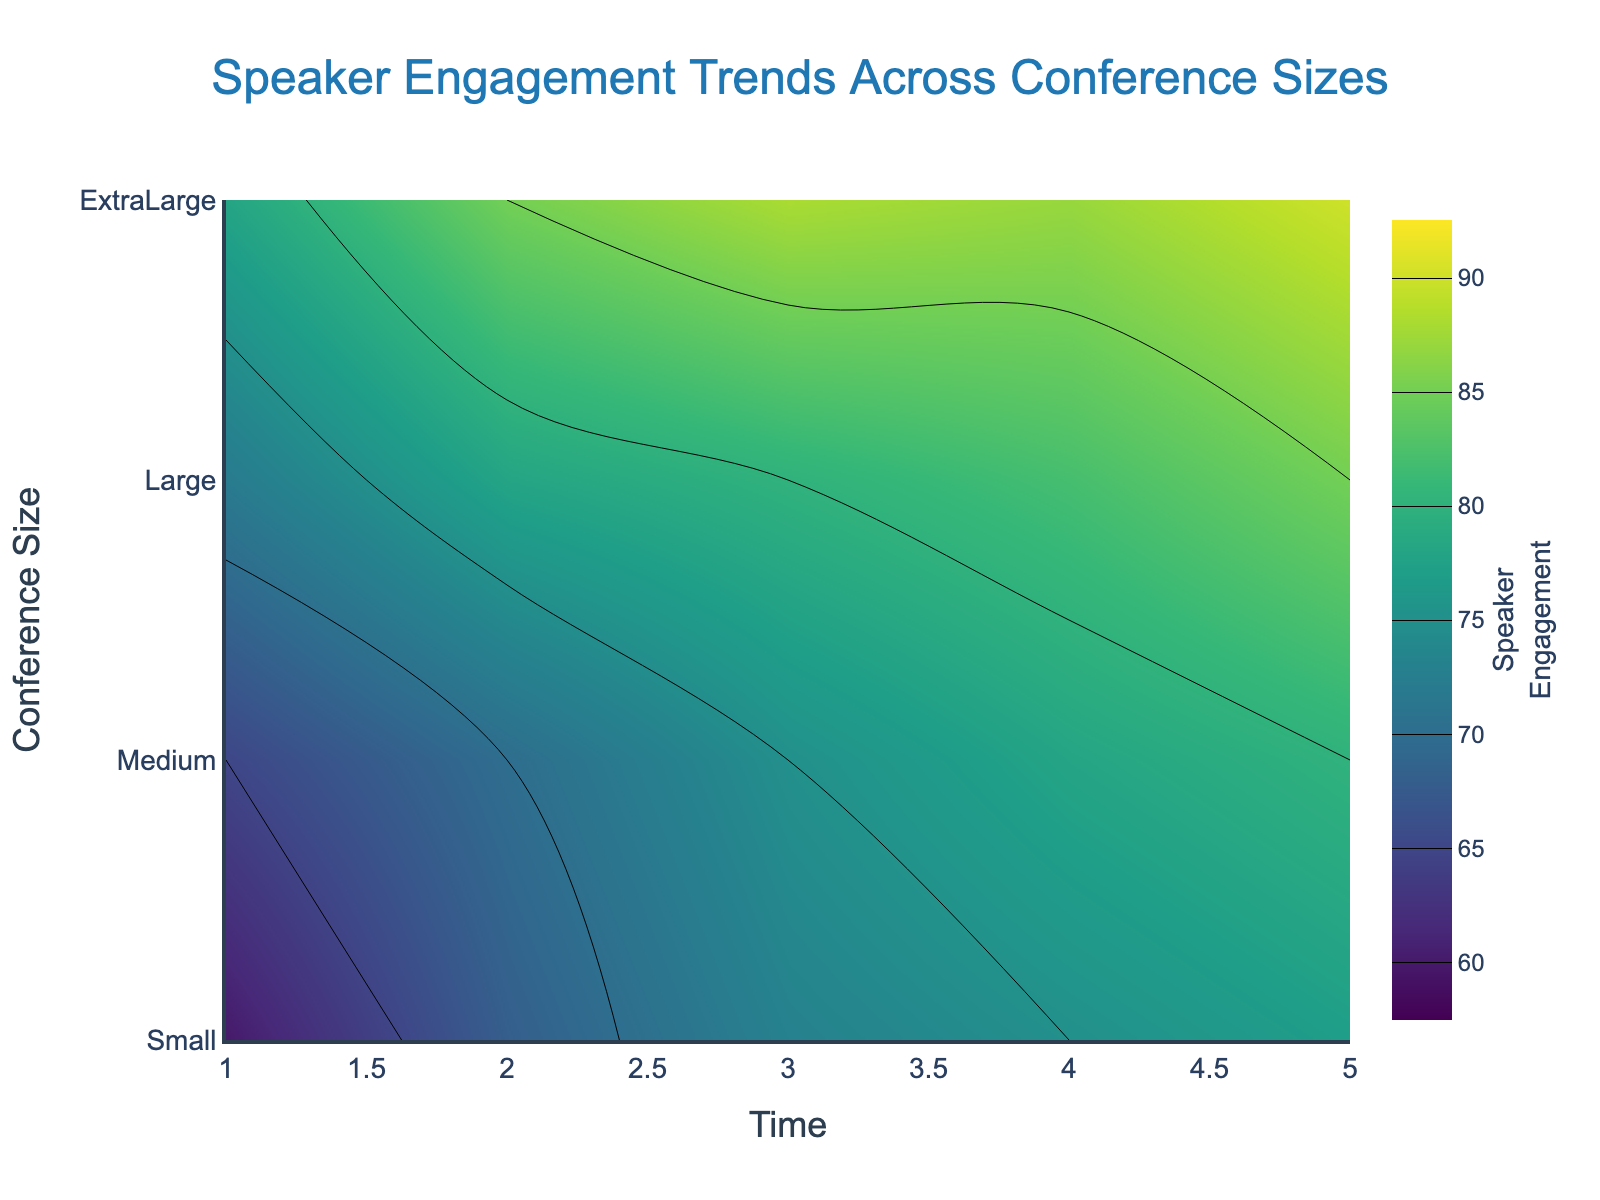How does speaker engagement change over time for a medium-sized conference? Speaker engagement for a medium-sized conference increases steadily from 72 to 85 as the time progresses from 1 to 5.
Answer: It increases from 72 to 85 Which conference size shows the highest initial speaker engagement? The small-sized conference shows the highest initial speaker engagement of 78, compared to medium (72), large (65), and extra-large (60) sizes.
Answer: Small Between which two time points is the increase in speaker engagement the highest for a large conference? For a large conference, the increase in speaker engagement is highest between time points 2 and 3, rising from 70 to 75, a difference of 5 units. Other increases are smaller.
Answer: Between 2 and 3 What overall trend in speaker engagement can be observed as conference size increases over five-time points? As the conference size increases, the initial speaker engagement starts lower (highest for small, lowest for extra-large). Engagement increases over time for all sizes, but final engagement is lower for larger conferences.
Answer: Engagement starts lower for larger conferences Which contour bands are color-coded for speaker engagement values, and what do they signify? The contour bands are color-coded using the 'Viridis' colorscale, ranging from 60 to 90 in steps of 5. Each band represents different levels of speaker engagement, with darker colors indicating lower engagement and lighter colors indicating higher engagement.
Answer: Bands from 60 to 90 in steps of 5 At which time point do small and medium conference sizes reach an equal speaker engagement value, and what is that value? By inspecting the contour lines, small and medium conference sizes both reach a speaker engagement value of 85 at time point 5.
Answer: Time point 5, value 85 What is the overall shape of the speaker engagement trend across different conference sizes? The overall shape of the trend for speaker engagement as visualized by the contour plot indicates an upward trend for all conference sizes over time, with variations in initial and final engagement levels across sizes.
Answer: Upward trend Which conference size shows the least overall change in speaker engagement over time, and what is the change value? The small-sized conference shows the least overall change, starting at 78 and ending at 90, resulting in a change of 12 units.
Answer: Small, 12 units 